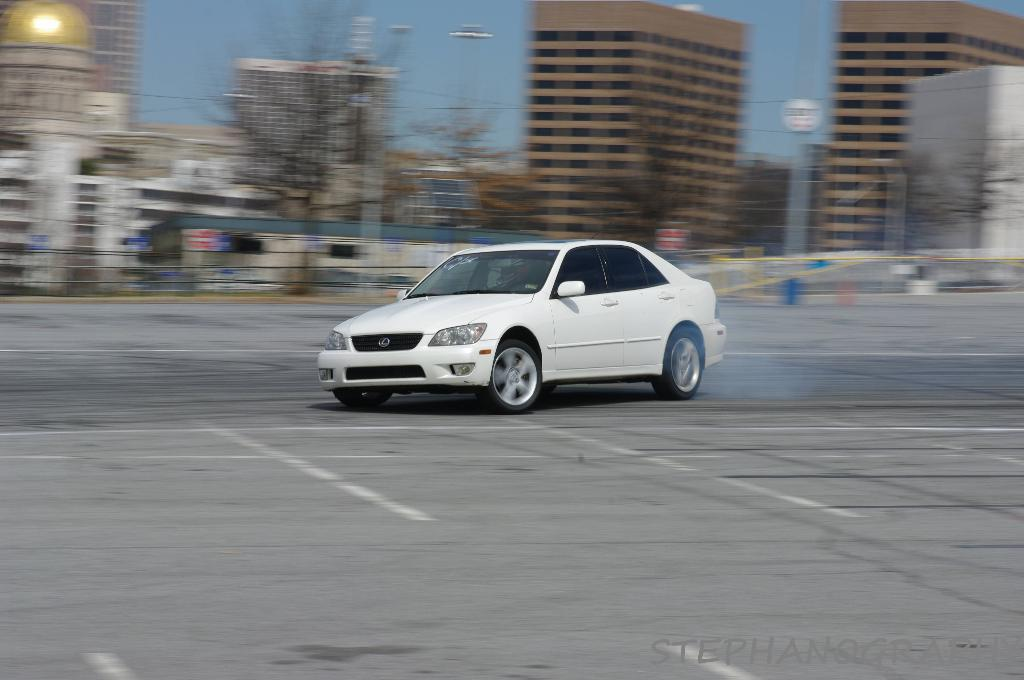What type of vehicle is in the image? There is a white car in the image. Where is the car located? The car is on a road. What can be seen in the background of the image? There are buildings in the background of the image. What is visible at the top of the image? The sky is visible at the top of the image. What action is the authority figure taking in the image? There is no authority figure present in the image, and therefore no action can be observed. 